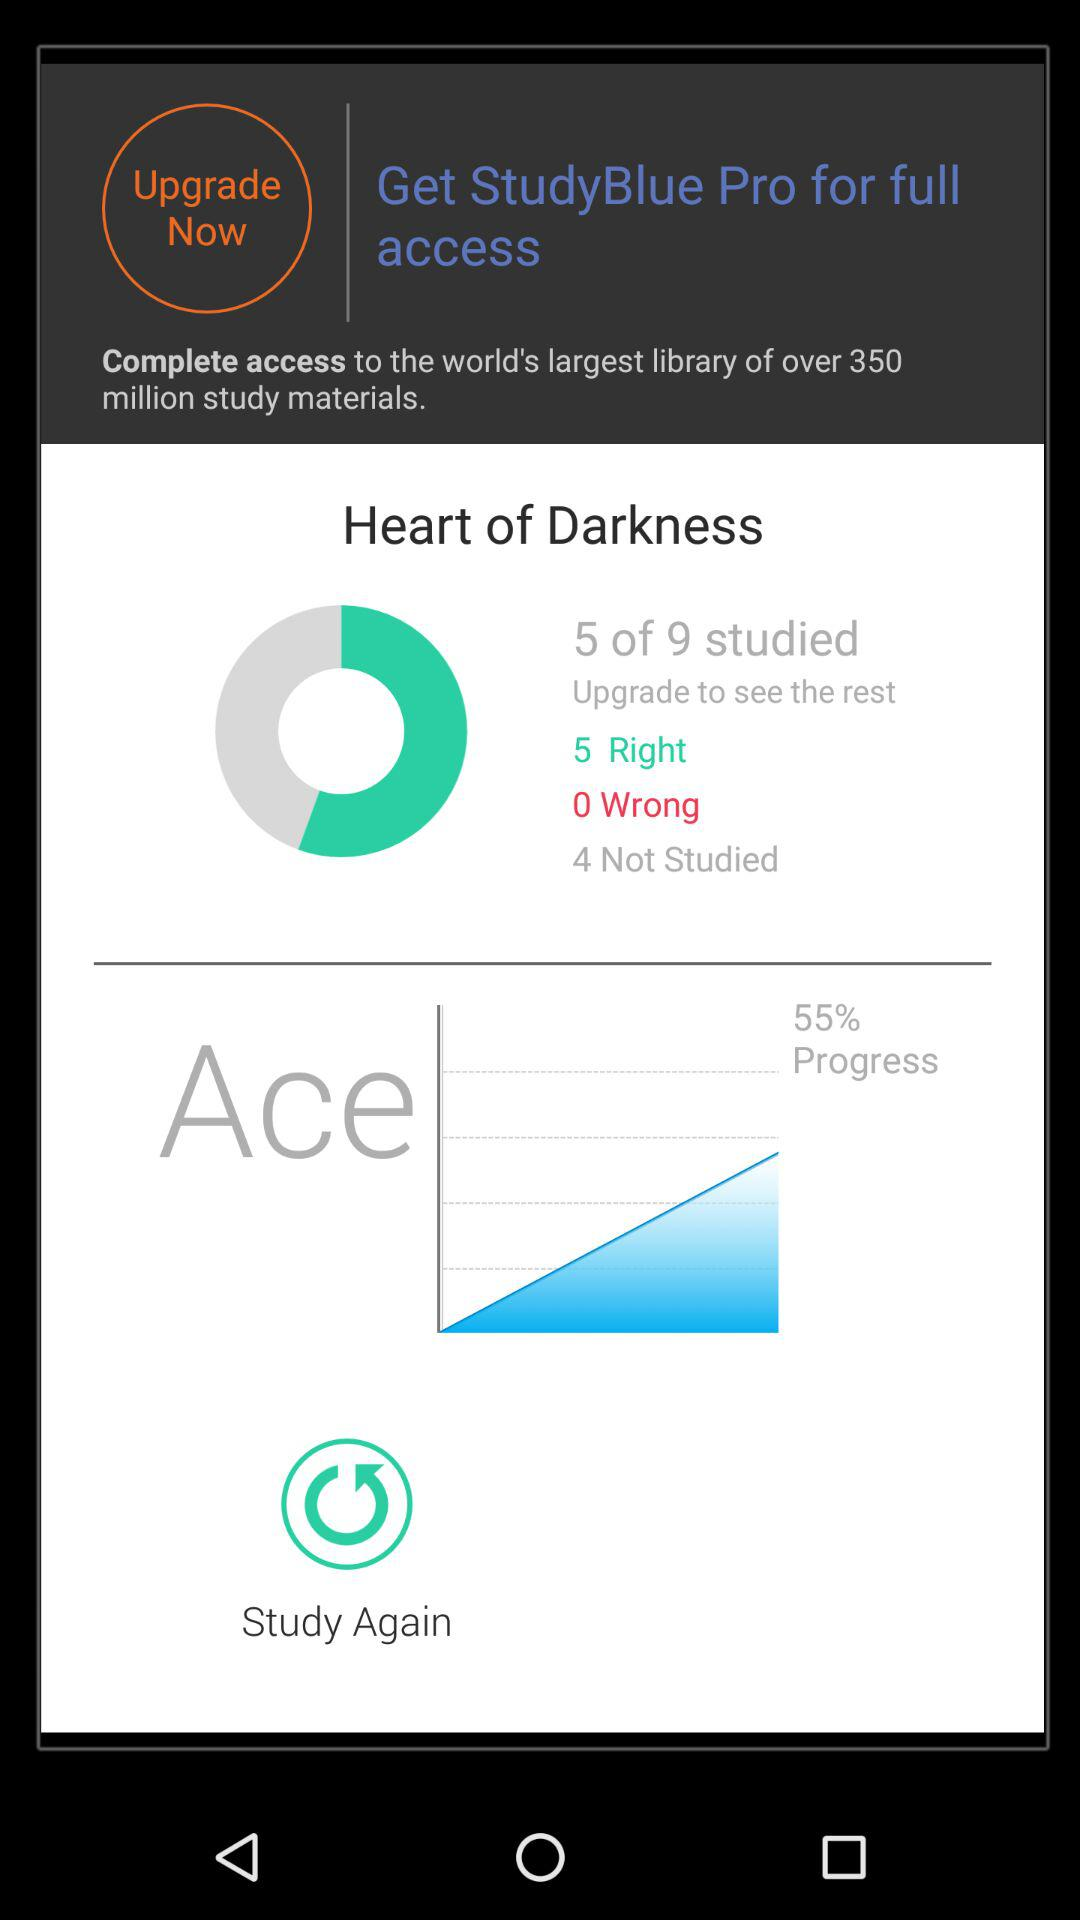How many out of 9 have studied? Out of 9, 5 have been studied. 